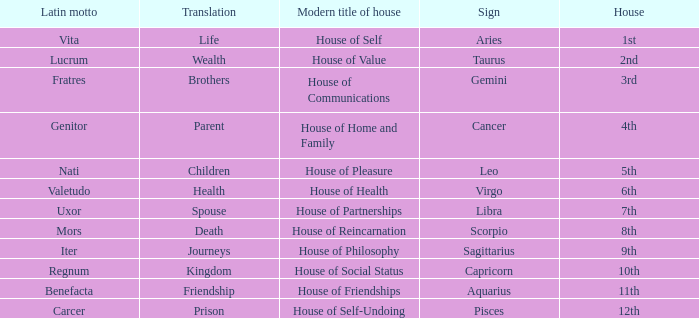What is the translation of the sign of Aquarius? Friendship. 